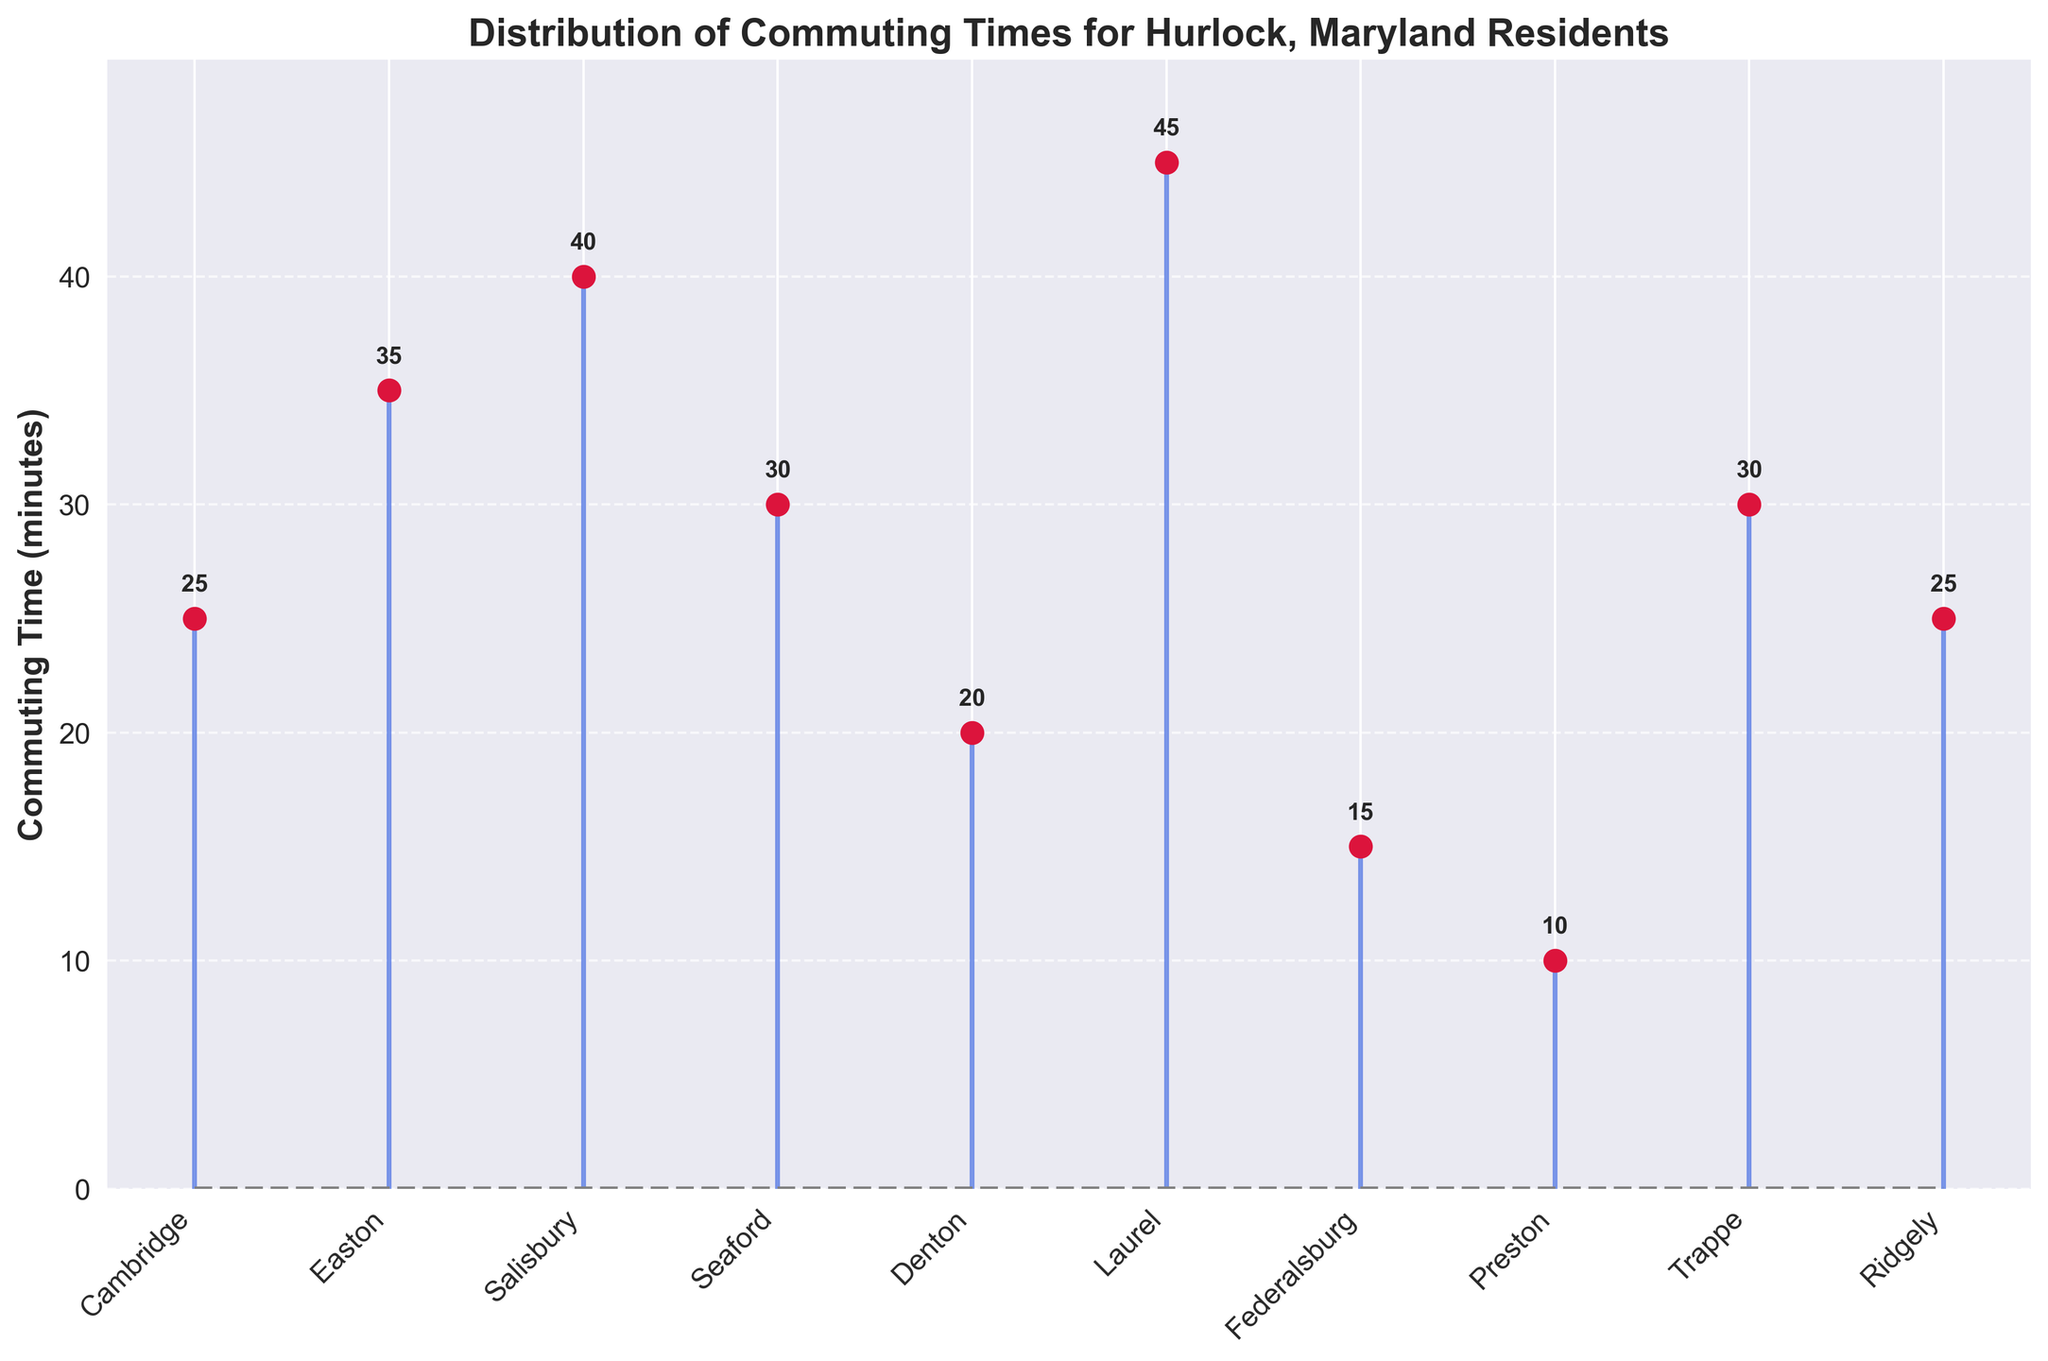What is the title of the plot? The title of the plot is given at the top and it states the subject of the plot. The title is "Distribution of Commuting Times for Hurlock, Maryland Residents".
Answer: Distribution of Commuting Times for Hurlock, Maryland Residents How many cities are listed in the plot? Each city's name is listed along the x-axis. If you count them, you will see that there are 10 cities listed.
Answer: 10 Which city has the shortest commuting time? By looking at the stem plot, the shortest stem (lowest point) represents the shortest commuting time, which corresponds to Preston at 10 minutes.
Answer: Preston How many cities have a commuting time of 30 minutes or more? Identify the cities with stems extending to at least the 30-minute mark. The cities are Easton, Salisbury, Seaford, Trappe, and Laurel, totalling 5 cities.
Answer: 5 Which city has the highest commuting time and what is it? The highest point in the plot represents the city with the longest commuting time, which is Laurel at 45 minutes.
Answer: Laurel, 45 minutes What is the average commuting time for all the cities? Add all the commuting times together (25+35+40+30+20+45+15+10+30+25 = 275) and then divide by the number of cities (10). The average is 275 / 10 = 27.5 minutes.
Answer: 27.5 minutes Which city has a commuting time closest to the average commuting time? The average commuting time is 27.5 minutes. Compare this with the listed commuting times. The closest is Ridgely at 25 minutes.
Answer: Ridgely How much longer is the commute to Laurel compared to Federalsburg? Subtract the commuting time of Federalsburg (15 minutes) from that of Laurel (45 minutes). The difference is 45 - 15 = 30 minutes.
Answer: 30 minutes Are there any cities with the same commuting time? By checking the plotted data points, Trappe and Seaford both have a commuting time of 30 minutes.
Answer: Yes, Trappe and Seaford What is the median commuting time of the listed cities? Sort the commuting times: [10, 15, 20, 25, 25, 30, 30, 35, 40, 45]. The median value, which is the average of the 5th and 6th values, is (25 + 30) / 2 = 27.5 minutes.
Answer: 27.5 minutes 